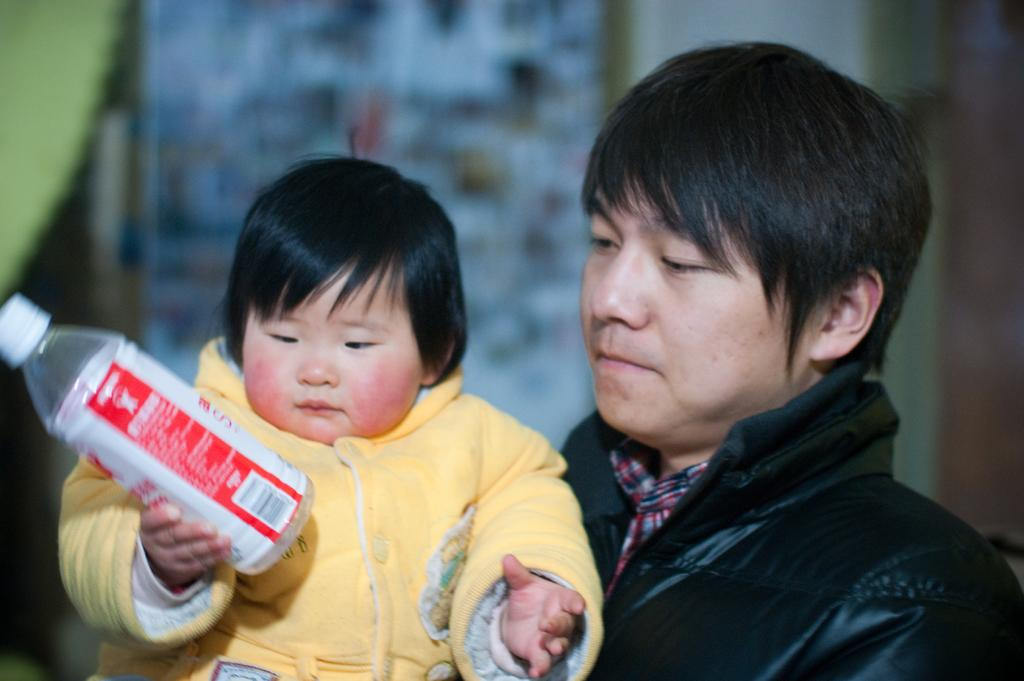Who is the main subject in the image? There is a man in the image. What is the man doing in the image? The man is holding a baby. What is the baby holding in the image? The baby is holding a bottle. What type of volcano can be seen erupting in the background of the image? There is no volcano present in the image; it features a man holding a baby who is holding a bottle. 